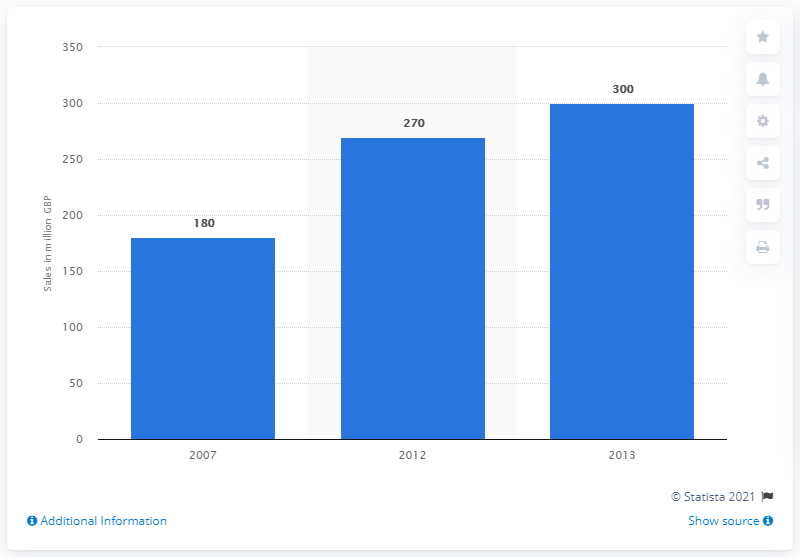List a handful of essential elements in this visual. In the year 2007, the annual sales value of wool produced in the UK reached a significant milestone. In 2007, the sales value of British wool was approximately 180 million GBP. In 2013, the sales value of British wool was 300 million. 